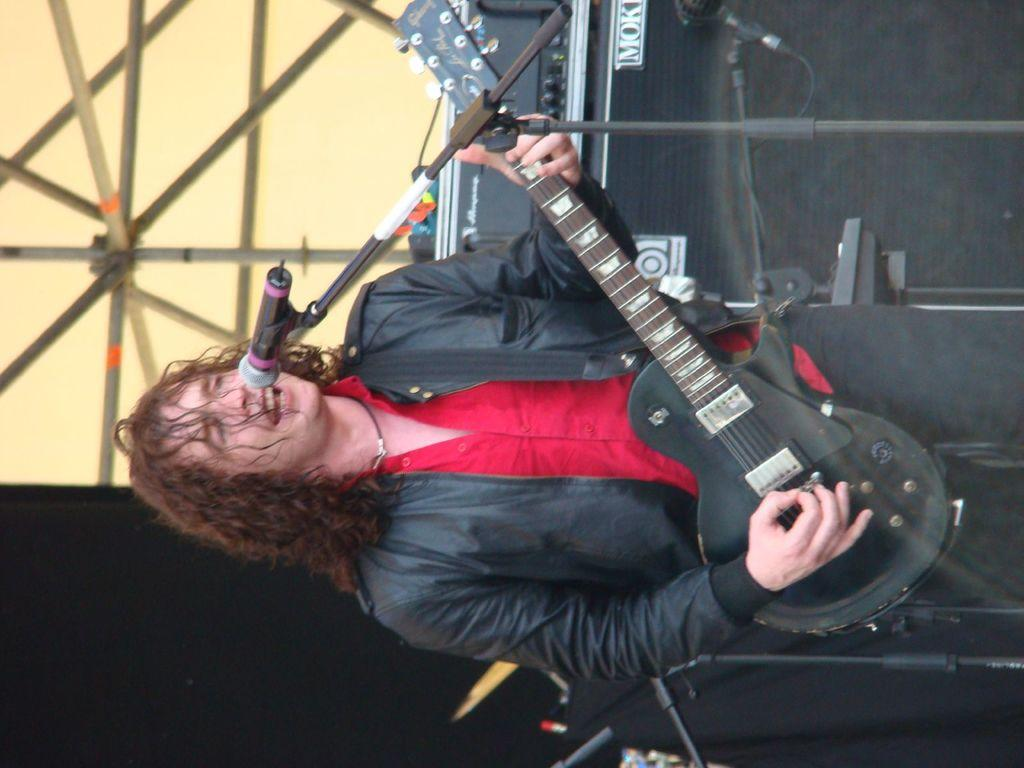What is the person in the image doing? The person is playing a guitar and singing. What object is the person using to amplify their voice? There is a microphone in the image, which is an electrical device. What type of popcorn is being served in the image? There is no popcorn present in the image. Is the person in the image performing in a cave? The image does not provide any information about the location or setting of the performance, so it cannot be determined if it is in a cave or not. 